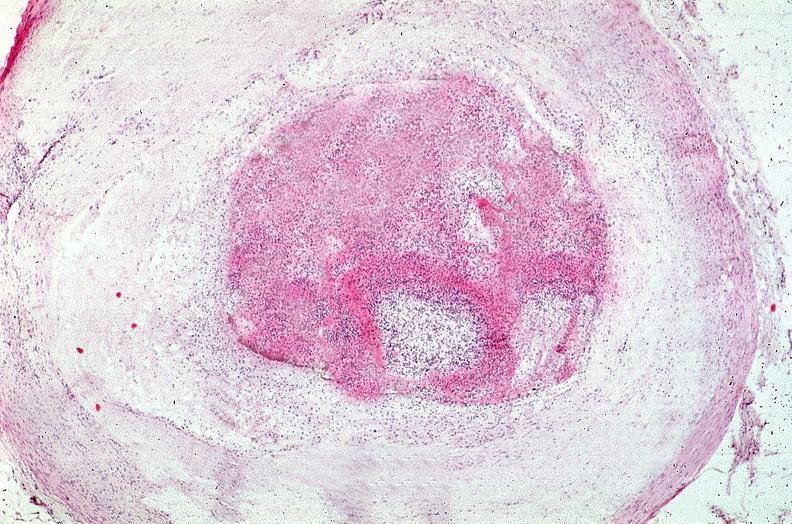what is present?
Answer the question using a single word or phrase. Vasculature 